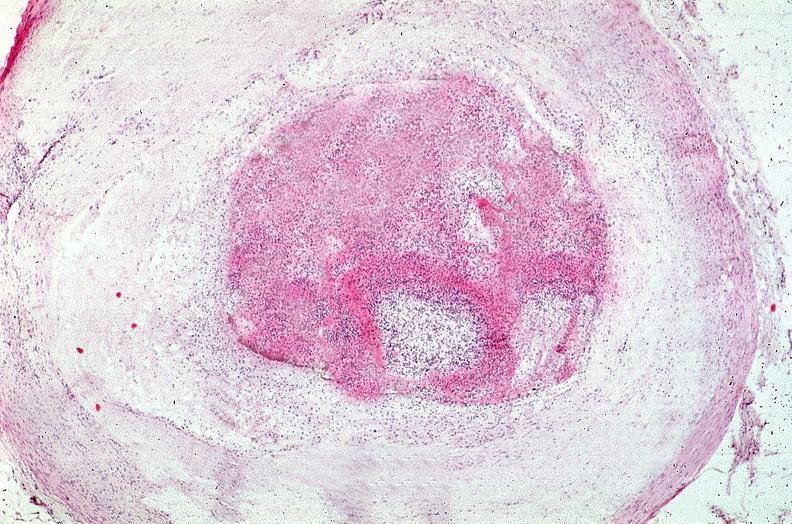what is present?
Answer the question using a single word or phrase. Vasculature 